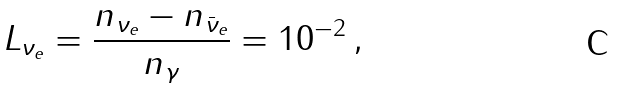<formula> <loc_0><loc_0><loc_500><loc_500>L _ { \nu _ { e } } = \frac { n _ { \nu _ { e } } - n _ { \bar { \nu } _ { e } } } { n _ { \gamma } } = 1 0 ^ { - 2 } \, ,</formula> 